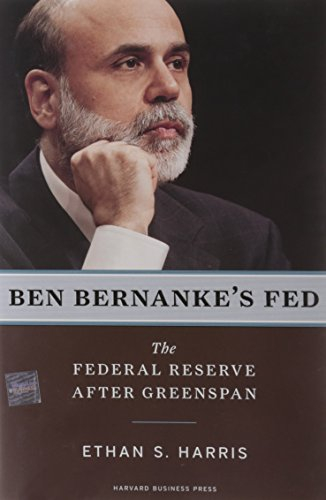Who is the author of this book? The author of the book displayed is Ethan S. Harris, who is known for his work on economic policy and central banking. 